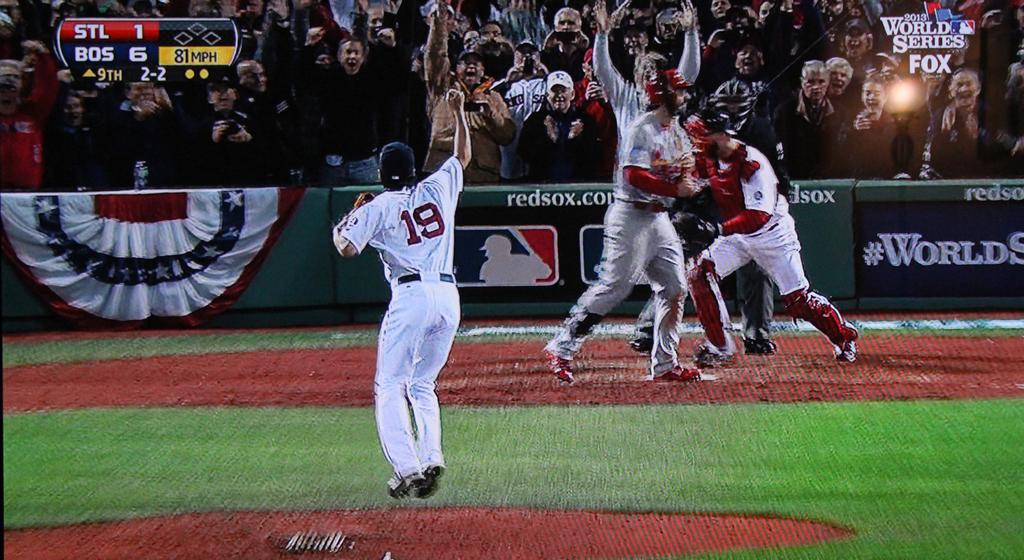What is the number of the player who is pitching?
Provide a short and direct response. 19. What sports team is mentioned on the green wall?
Ensure brevity in your answer.  Red sox. 